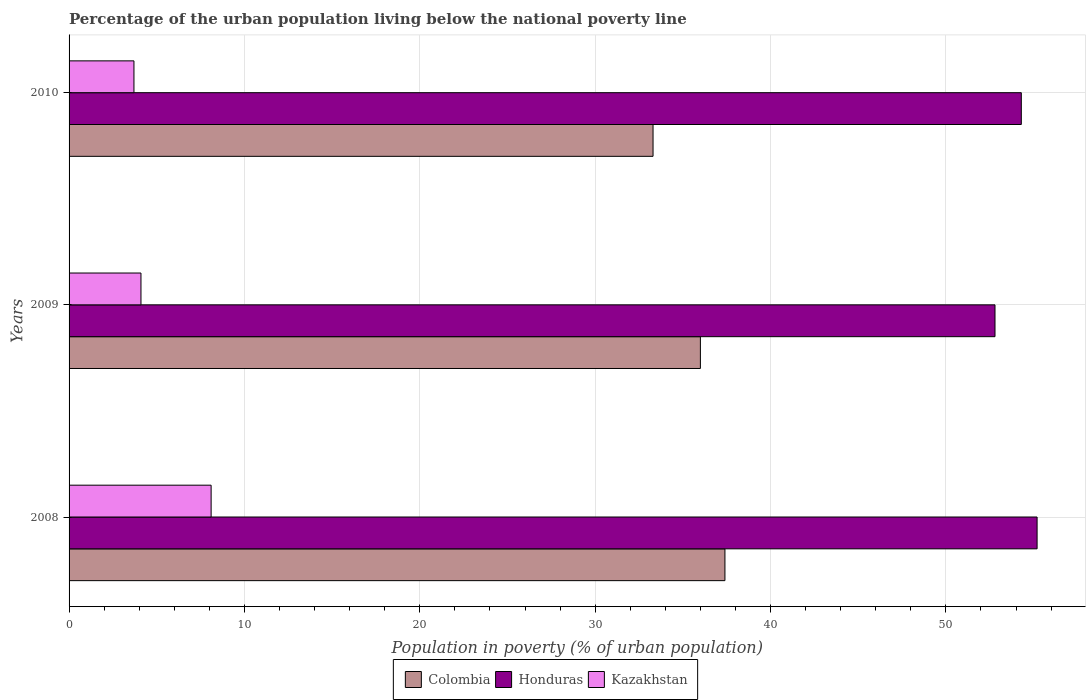How many bars are there on the 3rd tick from the top?
Provide a short and direct response. 3. How many bars are there on the 3rd tick from the bottom?
Your response must be concise. 3. What is the label of the 2nd group of bars from the top?
Offer a terse response. 2009. What is the percentage of the urban population living below the national poverty line in Kazakhstan in 2008?
Give a very brief answer. 8.1. Across all years, what is the maximum percentage of the urban population living below the national poverty line in Honduras?
Your answer should be very brief. 55.2. Across all years, what is the minimum percentage of the urban population living below the national poverty line in Honduras?
Make the answer very short. 52.8. In which year was the percentage of the urban population living below the national poverty line in Kazakhstan maximum?
Your response must be concise. 2008. In which year was the percentage of the urban population living below the national poverty line in Honduras minimum?
Offer a very short reply. 2009. What is the total percentage of the urban population living below the national poverty line in Honduras in the graph?
Provide a short and direct response. 162.3. What is the difference between the percentage of the urban population living below the national poverty line in Kazakhstan in 2009 and that in 2010?
Provide a succinct answer. 0.4. What is the difference between the percentage of the urban population living below the national poverty line in Kazakhstan in 2009 and the percentage of the urban population living below the national poverty line in Honduras in 2008?
Make the answer very short. -51.1. What is the average percentage of the urban population living below the national poverty line in Honduras per year?
Offer a very short reply. 54.1. In the year 2010, what is the difference between the percentage of the urban population living below the national poverty line in Honduras and percentage of the urban population living below the national poverty line in Kazakhstan?
Your response must be concise. 50.6. What is the ratio of the percentage of the urban population living below the national poverty line in Colombia in 2008 to that in 2010?
Your answer should be compact. 1.12. Is the percentage of the urban population living below the national poverty line in Kazakhstan in 2009 less than that in 2010?
Make the answer very short. No. What is the difference between the highest and the lowest percentage of the urban population living below the national poverty line in Colombia?
Make the answer very short. 4.1. In how many years, is the percentage of the urban population living below the national poverty line in Colombia greater than the average percentage of the urban population living below the national poverty line in Colombia taken over all years?
Offer a terse response. 2. What does the 2nd bar from the top in 2010 represents?
Ensure brevity in your answer.  Honduras. What does the 2nd bar from the bottom in 2009 represents?
Your answer should be compact. Honduras. Are all the bars in the graph horizontal?
Your answer should be compact. Yes. What is the difference between two consecutive major ticks on the X-axis?
Your response must be concise. 10. Are the values on the major ticks of X-axis written in scientific E-notation?
Provide a succinct answer. No. What is the title of the graph?
Your answer should be very brief. Percentage of the urban population living below the national poverty line. Does "New Caledonia" appear as one of the legend labels in the graph?
Give a very brief answer. No. What is the label or title of the X-axis?
Offer a very short reply. Population in poverty (% of urban population). What is the label or title of the Y-axis?
Ensure brevity in your answer.  Years. What is the Population in poverty (% of urban population) in Colombia in 2008?
Keep it short and to the point. 37.4. What is the Population in poverty (% of urban population) in Honduras in 2008?
Make the answer very short. 55.2. What is the Population in poverty (% of urban population) of Kazakhstan in 2008?
Provide a succinct answer. 8.1. What is the Population in poverty (% of urban population) of Colombia in 2009?
Your answer should be compact. 36. What is the Population in poverty (% of urban population) of Honduras in 2009?
Your answer should be very brief. 52.8. What is the Population in poverty (% of urban population) in Kazakhstan in 2009?
Keep it short and to the point. 4.1. What is the Population in poverty (% of urban population) of Colombia in 2010?
Provide a succinct answer. 33.3. What is the Population in poverty (% of urban population) of Honduras in 2010?
Provide a short and direct response. 54.3. Across all years, what is the maximum Population in poverty (% of urban population) in Colombia?
Make the answer very short. 37.4. Across all years, what is the maximum Population in poverty (% of urban population) in Honduras?
Keep it short and to the point. 55.2. Across all years, what is the minimum Population in poverty (% of urban population) of Colombia?
Ensure brevity in your answer.  33.3. Across all years, what is the minimum Population in poverty (% of urban population) in Honduras?
Your answer should be very brief. 52.8. Across all years, what is the minimum Population in poverty (% of urban population) in Kazakhstan?
Ensure brevity in your answer.  3.7. What is the total Population in poverty (% of urban population) in Colombia in the graph?
Your answer should be very brief. 106.7. What is the total Population in poverty (% of urban population) in Honduras in the graph?
Your answer should be compact. 162.3. What is the total Population in poverty (% of urban population) in Kazakhstan in the graph?
Make the answer very short. 15.9. What is the difference between the Population in poverty (% of urban population) in Colombia in 2008 and that in 2009?
Provide a succinct answer. 1.4. What is the difference between the Population in poverty (% of urban population) in Colombia in 2008 and that in 2010?
Give a very brief answer. 4.1. What is the difference between the Population in poverty (% of urban population) in Honduras in 2008 and that in 2010?
Give a very brief answer. 0.9. What is the difference between the Population in poverty (% of urban population) of Honduras in 2009 and that in 2010?
Give a very brief answer. -1.5. What is the difference between the Population in poverty (% of urban population) of Colombia in 2008 and the Population in poverty (% of urban population) of Honduras in 2009?
Offer a terse response. -15.4. What is the difference between the Population in poverty (% of urban population) of Colombia in 2008 and the Population in poverty (% of urban population) of Kazakhstan in 2009?
Give a very brief answer. 33.3. What is the difference between the Population in poverty (% of urban population) in Honduras in 2008 and the Population in poverty (% of urban population) in Kazakhstan in 2009?
Keep it short and to the point. 51.1. What is the difference between the Population in poverty (% of urban population) in Colombia in 2008 and the Population in poverty (% of urban population) in Honduras in 2010?
Offer a terse response. -16.9. What is the difference between the Population in poverty (% of urban population) in Colombia in 2008 and the Population in poverty (% of urban population) in Kazakhstan in 2010?
Your answer should be compact. 33.7. What is the difference between the Population in poverty (% of urban population) of Honduras in 2008 and the Population in poverty (% of urban population) of Kazakhstan in 2010?
Your answer should be very brief. 51.5. What is the difference between the Population in poverty (% of urban population) in Colombia in 2009 and the Population in poverty (% of urban population) in Honduras in 2010?
Your response must be concise. -18.3. What is the difference between the Population in poverty (% of urban population) in Colombia in 2009 and the Population in poverty (% of urban population) in Kazakhstan in 2010?
Your answer should be very brief. 32.3. What is the difference between the Population in poverty (% of urban population) of Honduras in 2009 and the Population in poverty (% of urban population) of Kazakhstan in 2010?
Your response must be concise. 49.1. What is the average Population in poverty (% of urban population) in Colombia per year?
Your response must be concise. 35.57. What is the average Population in poverty (% of urban population) in Honduras per year?
Your response must be concise. 54.1. In the year 2008, what is the difference between the Population in poverty (% of urban population) of Colombia and Population in poverty (% of urban population) of Honduras?
Keep it short and to the point. -17.8. In the year 2008, what is the difference between the Population in poverty (% of urban population) of Colombia and Population in poverty (% of urban population) of Kazakhstan?
Your response must be concise. 29.3. In the year 2008, what is the difference between the Population in poverty (% of urban population) of Honduras and Population in poverty (% of urban population) of Kazakhstan?
Ensure brevity in your answer.  47.1. In the year 2009, what is the difference between the Population in poverty (% of urban population) of Colombia and Population in poverty (% of urban population) of Honduras?
Keep it short and to the point. -16.8. In the year 2009, what is the difference between the Population in poverty (% of urban population) of Colombia and Population in poverty (% of urban population) of Kazakhstan?
Your answer should be compact. 31.9. In the year 2009, what is the difference between the Population in poverty (% of urban population) of Honduras and Population in poverty (% of urban population) of Kazakhstan?
Keep it short and to the point. 48.7. In the year 2010, what is the difference between the Population in poverty (% of urban population) of Colombia and Population in poverty (% of urban population) of Honduras?
Keep it short and to the point. -21. In the year 2010, what is the difference between the Population in poverty (% of urban population) of Colombia and Population in poverty (% of urban population) of Kazakhstan?
Offer a very short reply. 29.6. In the year 2010, what is the difference between the Population in poverty (% of urban population) in Honduras and Population in poverty (% of urban population) in Kazakhstan?
Provide a short and direct response. 50.6. What is the ratio of the Population in poverty (% of urban population) of Colombia in 2008 to that in 2009?
Provide a short and direct response. 1.04. What is the ratio of the Population in poverty (% of urban population) in Honduras in 2008 to that in 2009?
Give a very brief answer. 1.05. What is the ratio of the Population in poverty (% of urban population) in Kazakhstan in 2008 to that in 2009?
Provide a succinct answer. 1.98. What is the ratio of the Population in poverty (% of urban population) of Colombia in 2008 to that in 2010?
Your response must be concise. 1.12. What is the ratio of the Population in poverty (% of urban population) in Honduras in 2008 to that in 2010?
Your response must be concise. 1.02. What is the ratio of the Population in poverty (% of urban population) in Kazakhstan in 2008 to that in 2010?
Give a very brief answer. 2.19. What is the ratio of the Population in poverty (% of urban population) in Colombia in 2009 to that in 2010?
Your response must be concise. 1.08. What is the ratio of the Population in poverty (% of urban population) of Honduras in 2009 to that in 2010?
Ensure brevity in your answer.  0.97. What is the ratio of the Population in poverty (% of urban population) of Kazakhstan in 2009 to that in 2010?
Offer a very short reply. 1.11. What is the difference between the highest and the second highest Population in poverty (% of urban population) of Honduras?
Make the answer very short. 0.9. What is the difference between the highest and the lowest Population in poverty (% of urban population) in Colombia?
Provide a short and direct response. 4.1. 